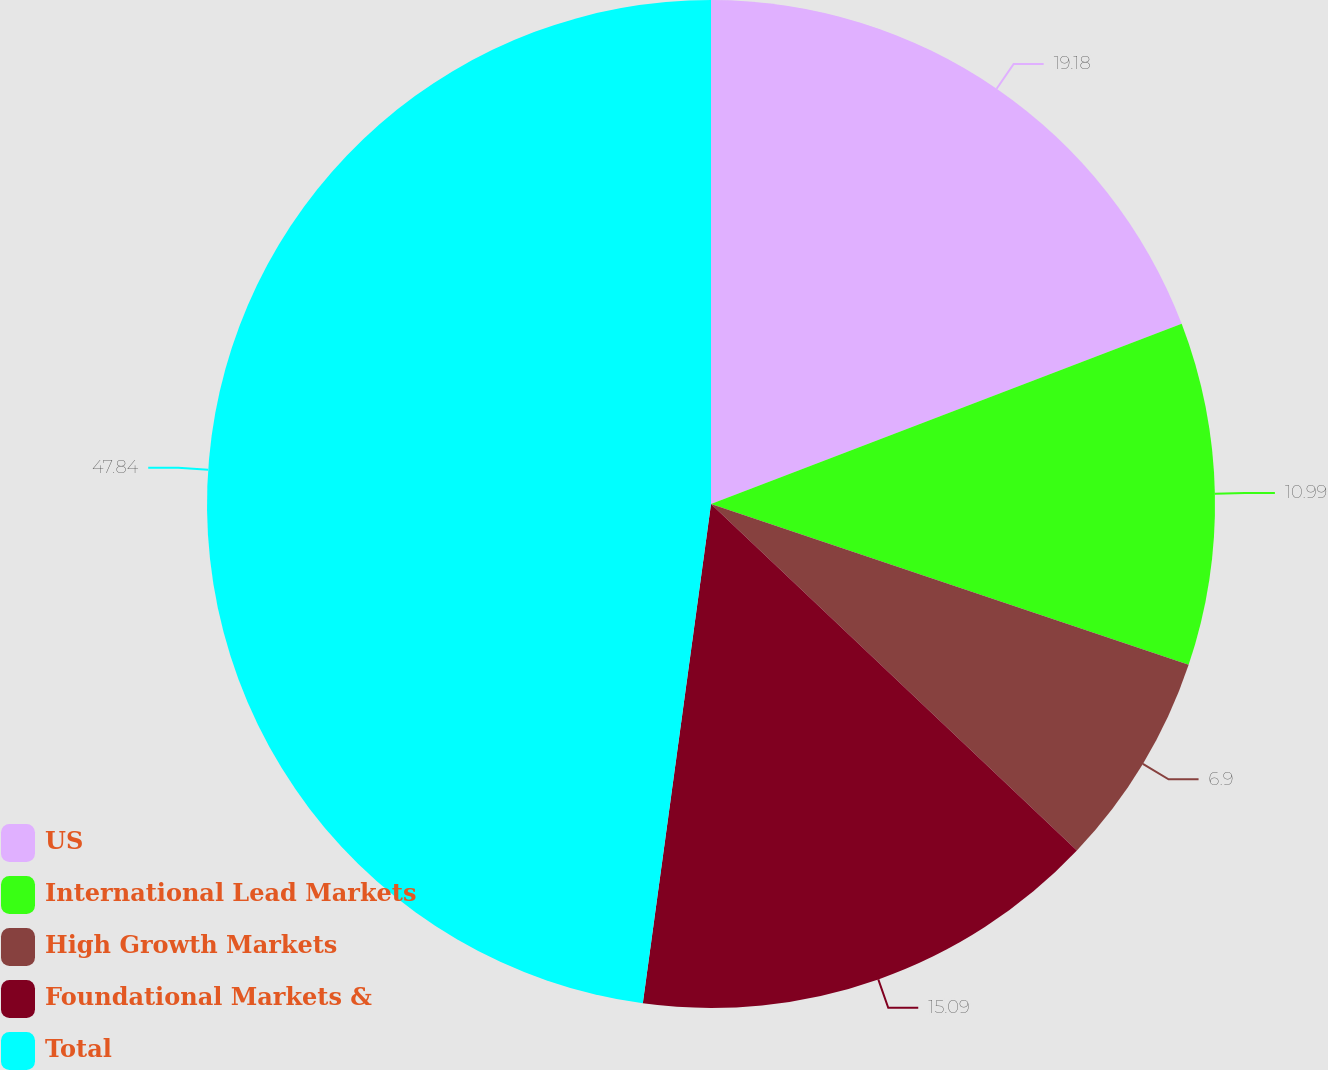<chart> <loc_0><loc_0><loc_500><loc_500><pie_chart><fcel>US<fcel>International Lead Markets<fcel>High Growth Markets<fcel>Foundational Markets &<fcel>Total<nl><fcel>19.18%<fcel>10.99%<fcel>6.9%<fcel>15.09%<fcel>47.84%<nl></chart> 